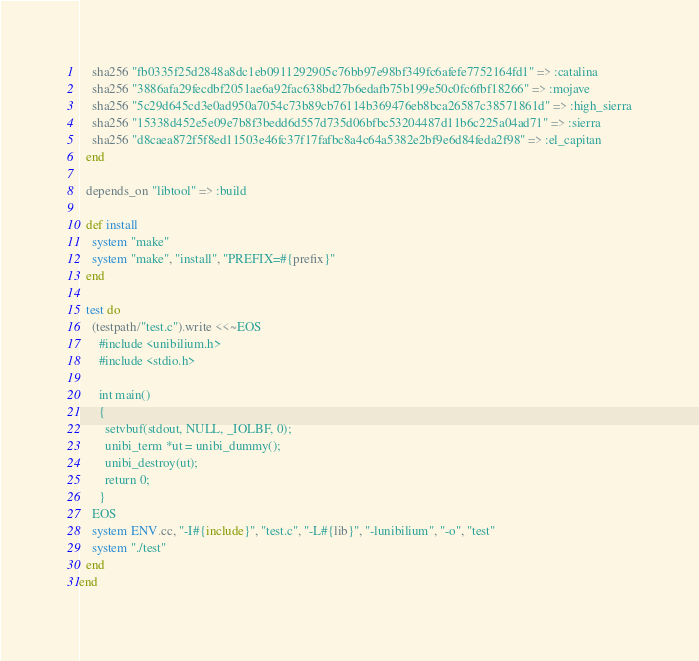<code> <loc_0><loc_0><loc_500><loc_500><_Ruby_>    sha256 "fb0335f25d2848a8dc1eb0911292905c76bb97e98bf349fc6afefe7752164fd1" => :catalina
    sha256 "3886afa29fecdbf2051ae6a92fac638bd27b6edafb75b199e50c0fc6fbf18266" => :mojave
    sha256 "5c29d645cd3e0ad950a7054c73b89cb76114b369476eb8bca26587c38571861d" => :high_sierra
    sha256 "15338d452e5e09e7b8f3bedd6d557d735d06bfbc53204487d11b6c225a04ad71" => :sierra
    sha256 "d8caea872f5f8ed11503e46fc37f17fafbc8a4c64a5382e2bf9e6d84feda2f98" => :el_capitan
  end

  depends_on "libtool" => :build

  def install
    system "make"
    system "make", "install", "PREFIX=#{prefix}"
  end

  test do
    (testpath/"test.c").write <<~EOS
      #include <unibilium.h>
      #include <stdio.h>

      int main()
      {
        setvbuf(stdout, NULL, _IOLBF, 0);
        unibi_term *ut = unibi_dummy();
        unibi_destroy(ut);
        return 0;
      }
    EOS
    system ENV.cc, "-I#{include}", "test.c", "-L#{lib}", "-lunibilium", "-o", "test"
    system "./test"
  end
end
</code> 